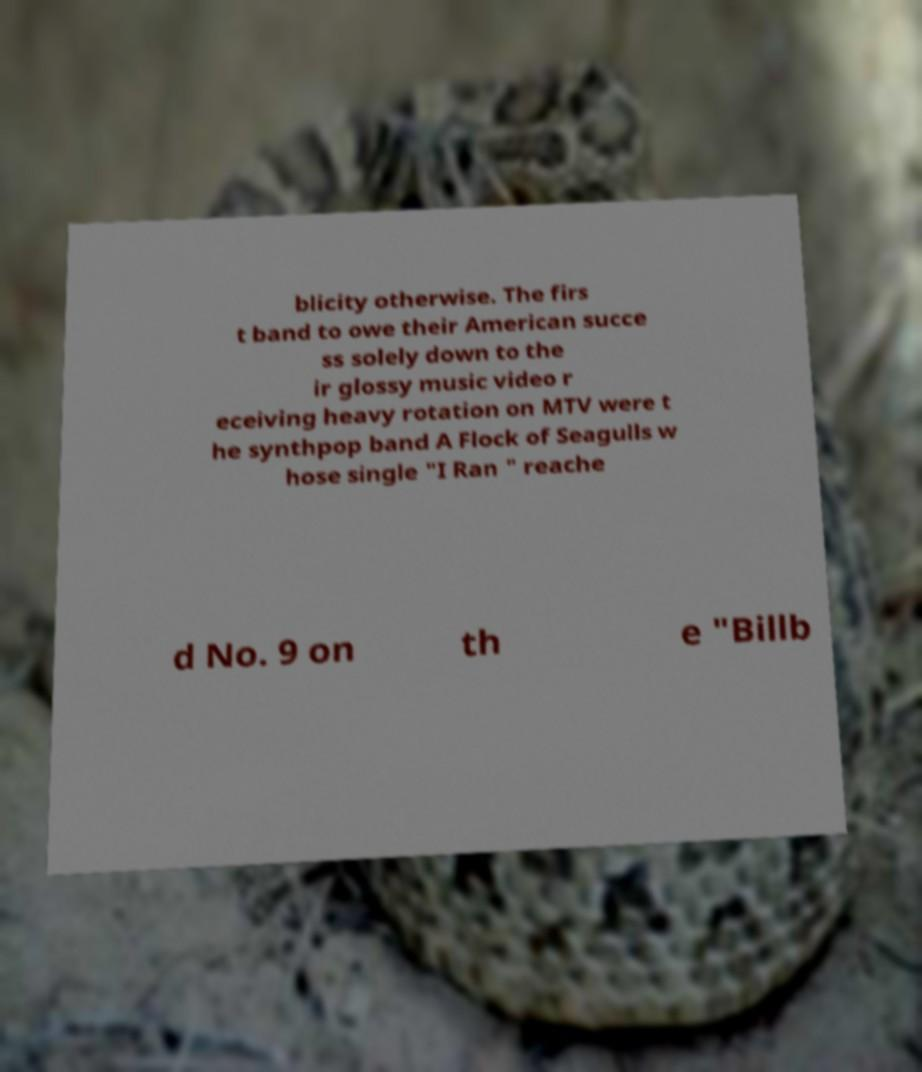Can you accurately transcribe the text from the provided image for me? blicity otherwise. The firs t band to owe their American succe ss solely down to the ir glossy music video r eceiving heavy rotation on MTV were t he synthpop band A Flock of Seagulls w hose single "I Ran " reache d No. 9 on th e "Billb 